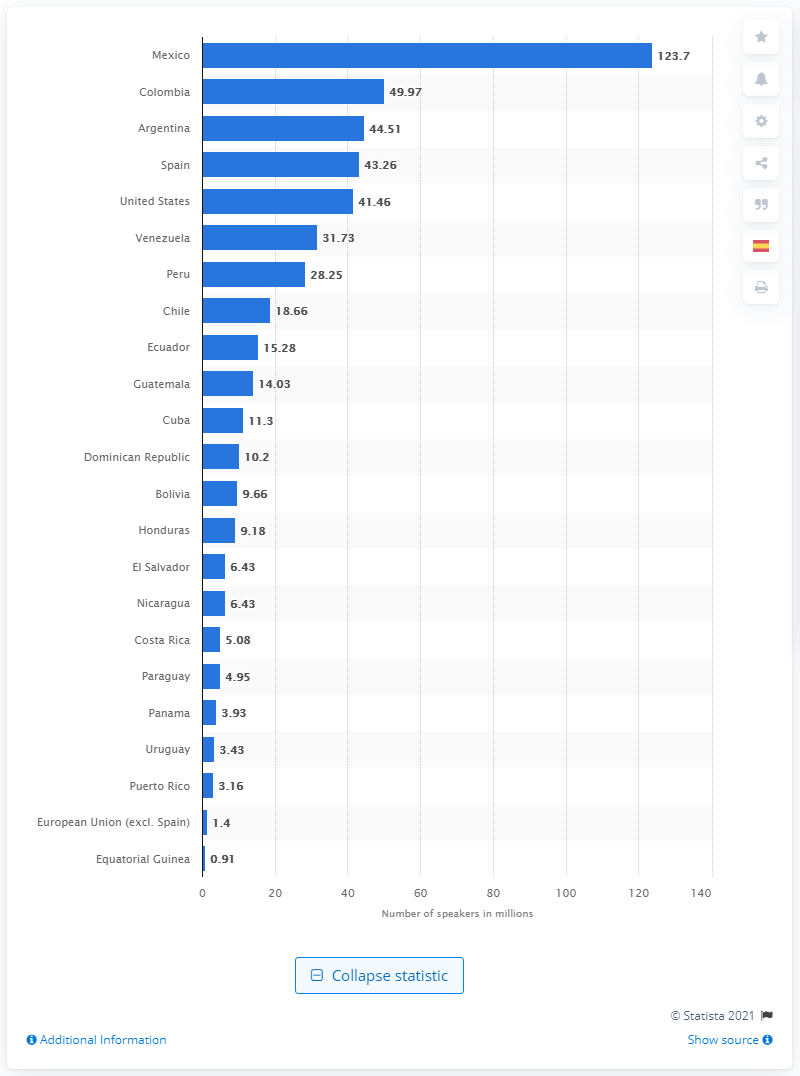List a handful of essential elements in this visual. Colombia has the second highest number of native Spanish speakers. According to recent statistics, 43.26% of the world's population speaks Spanish as their native language. Mexico has the largest number of native Spanish speakers in the world. According to a recent survey, it is estimated that over 123,700 people in Mexico speak Spanish with native proficiency. 